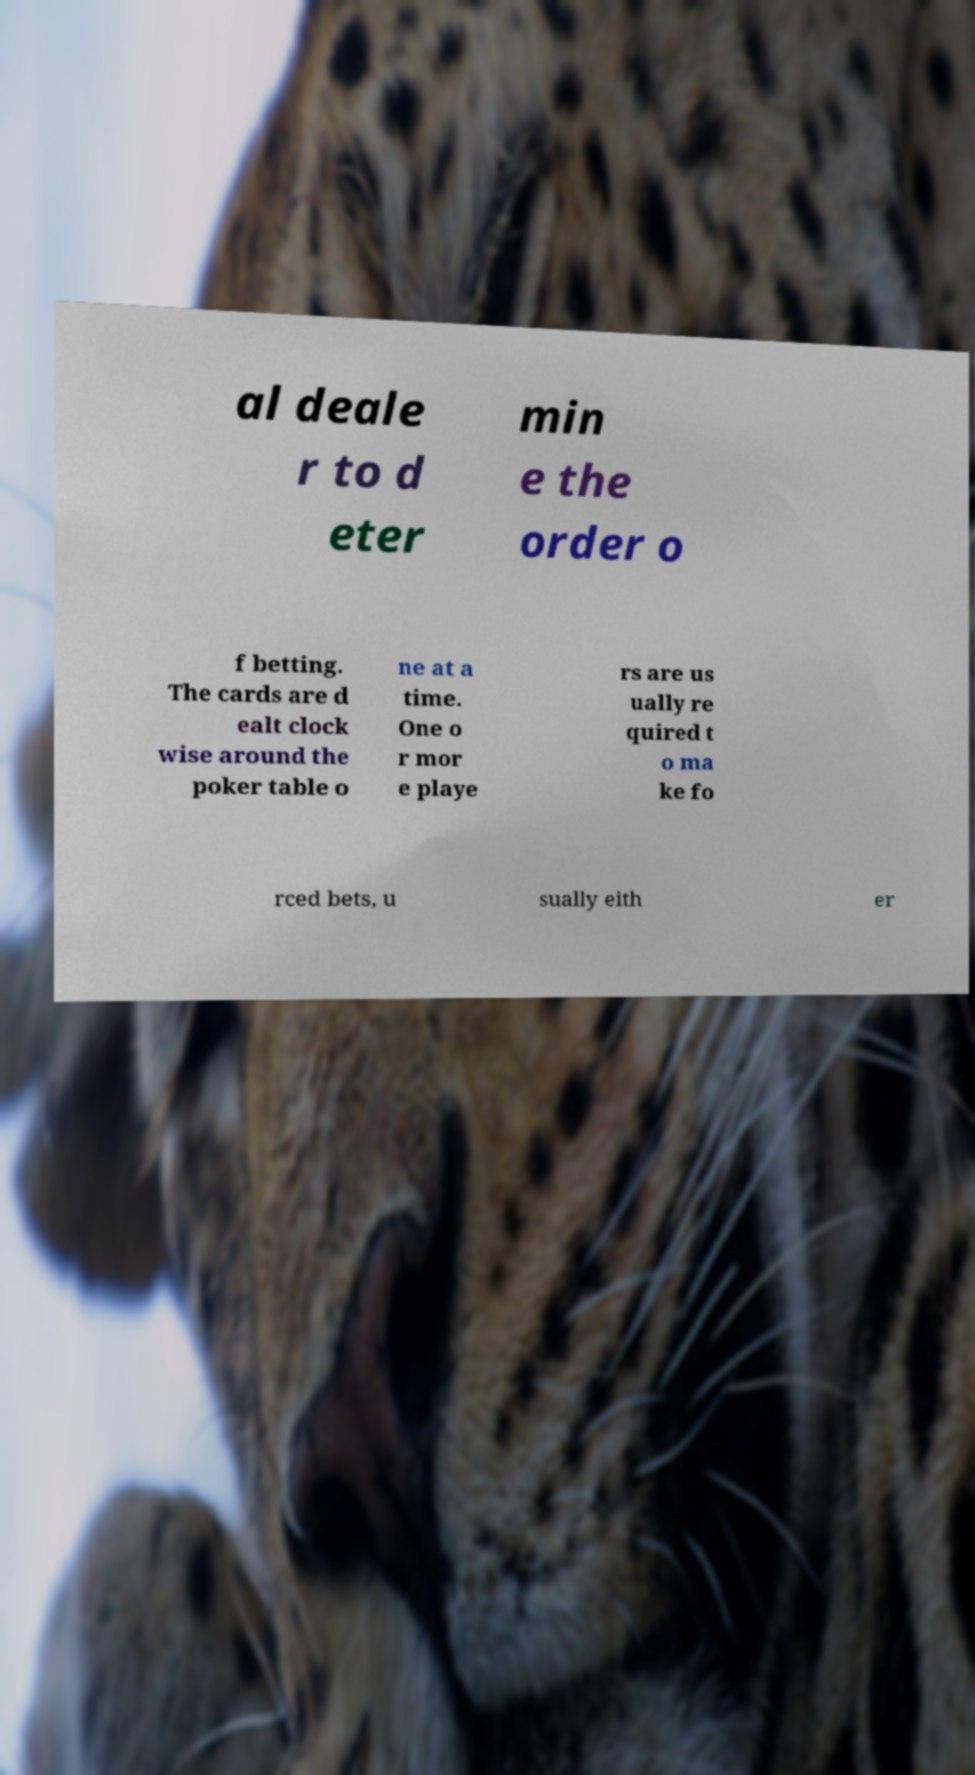What messages or text are displayed in this image? I need them in a readable, typed format. al deale r to d eter min e the order o f betting. The cards are d ealt clock wise around the poker table o ne at a time. One o r mor e playe rs are us ually re quired t o ma ke fo rced bets, u sually eith er 